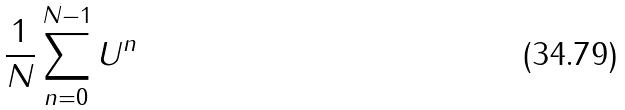<formula> <loc_0><loc_0><loc_500><loc_500>\frac { 1 } { N } \sum _ { n = 0 } ^ { N - 1 } U ^ { n }</formula> 